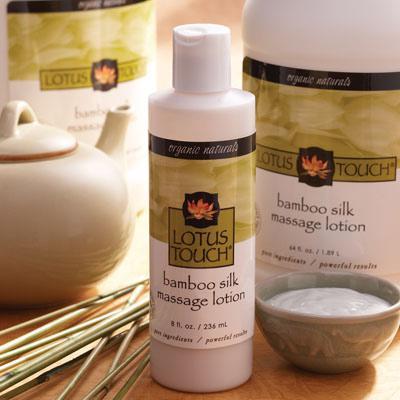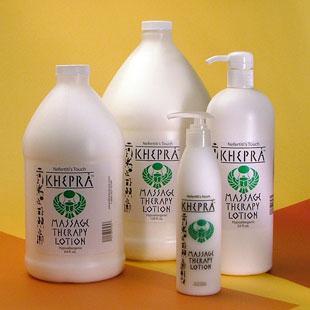The first image is the image on the left, the second image is the image on the right. Examine the images to the left and right. Is the description "There is a candle in one image." accurate? Answer yes or no. No. 